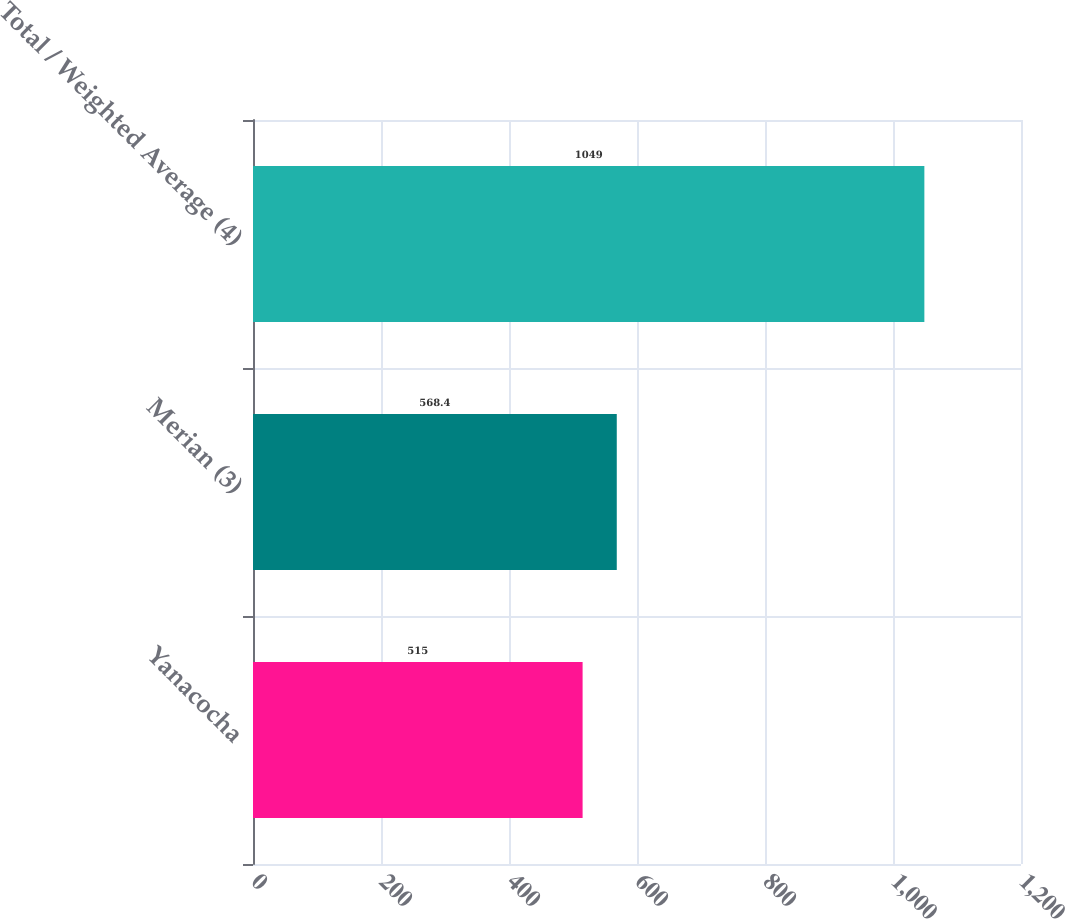Convert chart. <chart><loc_0><loc_0><loc_500><loc_500><bar_chart><fcel>Yanacocha<fcel>Merian (3)<fcel>Total / Weighted Average (4)<nl><fcel>515<fcel>568.4<fcel>1049<nl></chart> 